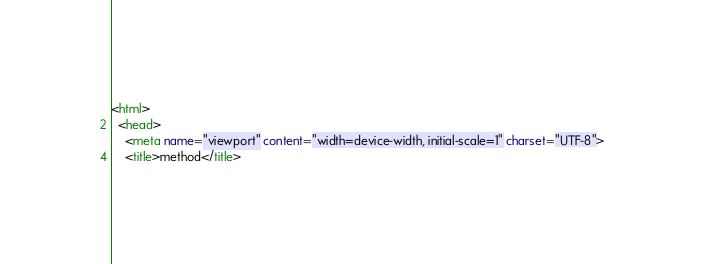<code> <loc_0><loc_0><loc_500><loc_500><_HTML_><html>
  <head>
    <meta name="viewport" content="width=device-width, initial-scale=1" charset="UTF-8">
    <title>method</title></code> 